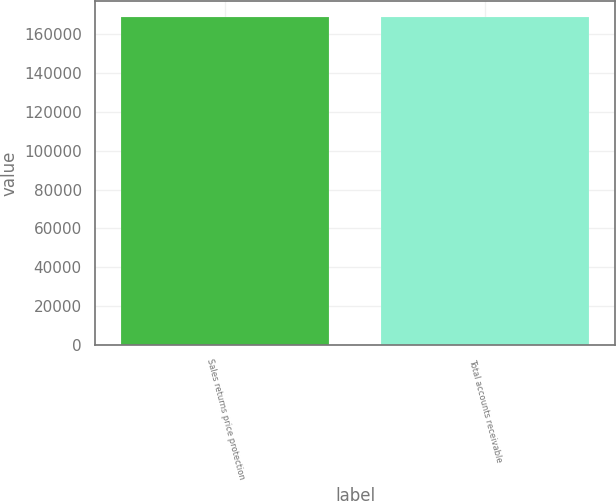Convert chart to OTSL. <chart><loc_0><loc_0><loc_500><loc_500><bar_chart><fcel>Sales returns price protection<fcel>Total accounts receivable<nl><fcel>168875<fcel>168875<nl></chart> 